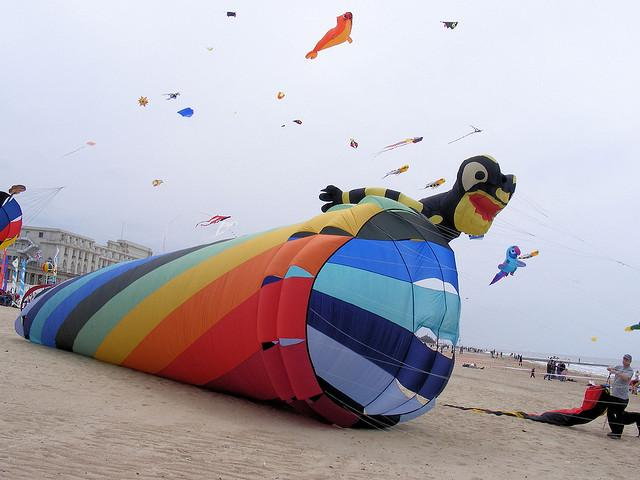What is the large item on the sand shaped like? Please explain your reasoning. traffic cone. The item in question has a circular base and comes to a point with a hollow interior which are all consistent characteristics of answer a. 